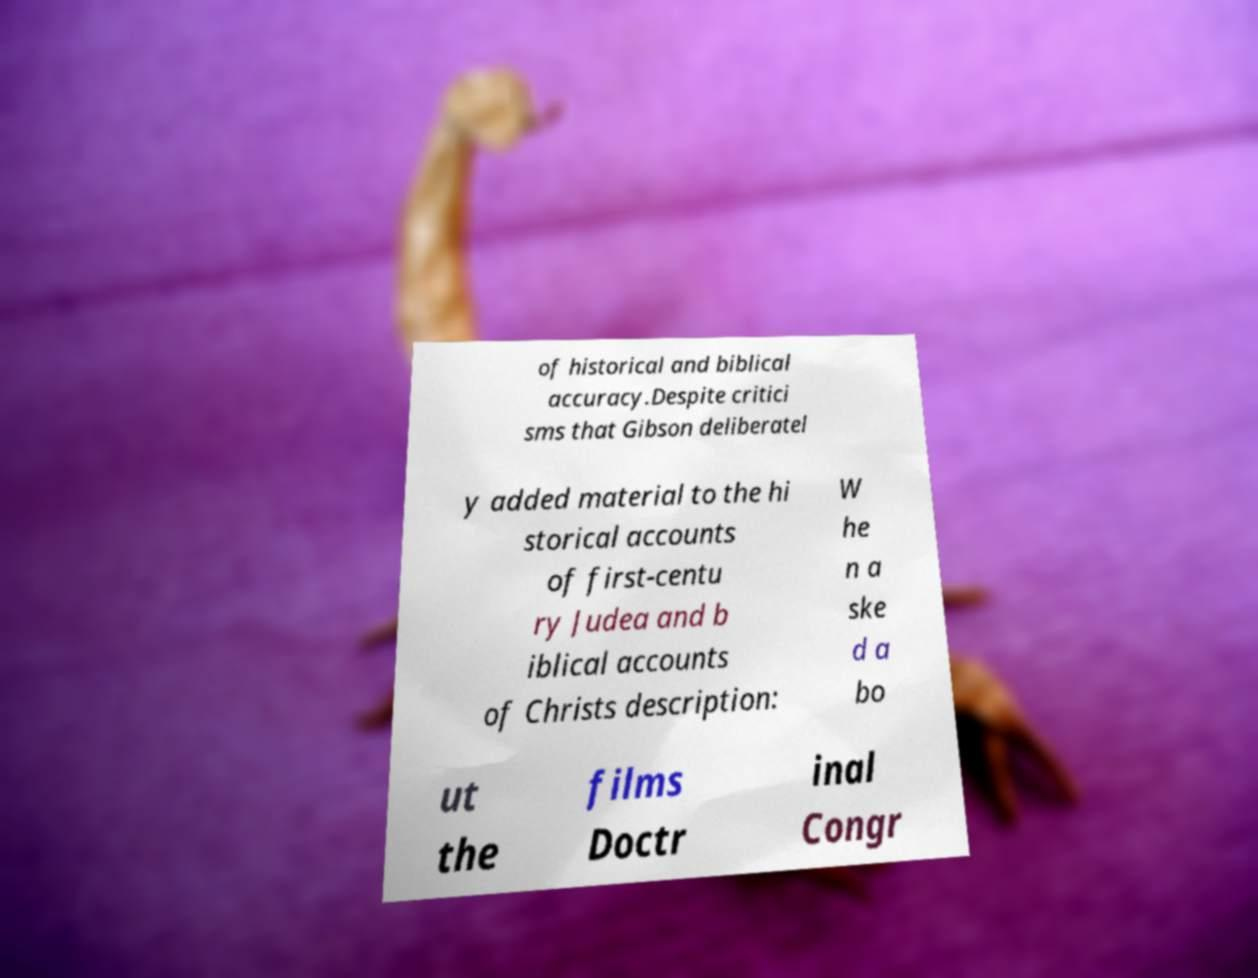What messages or text are displayed in this image? I need them in a readable, typed format. of historical and biblical accuracy.Despite critici sms that Gibson deliberatel y added material to the hi storical accounts of first-centu ry Judea and b iblical accounts of Christs description: W he n a ske d a bo ut the films Doctr inal Congr 